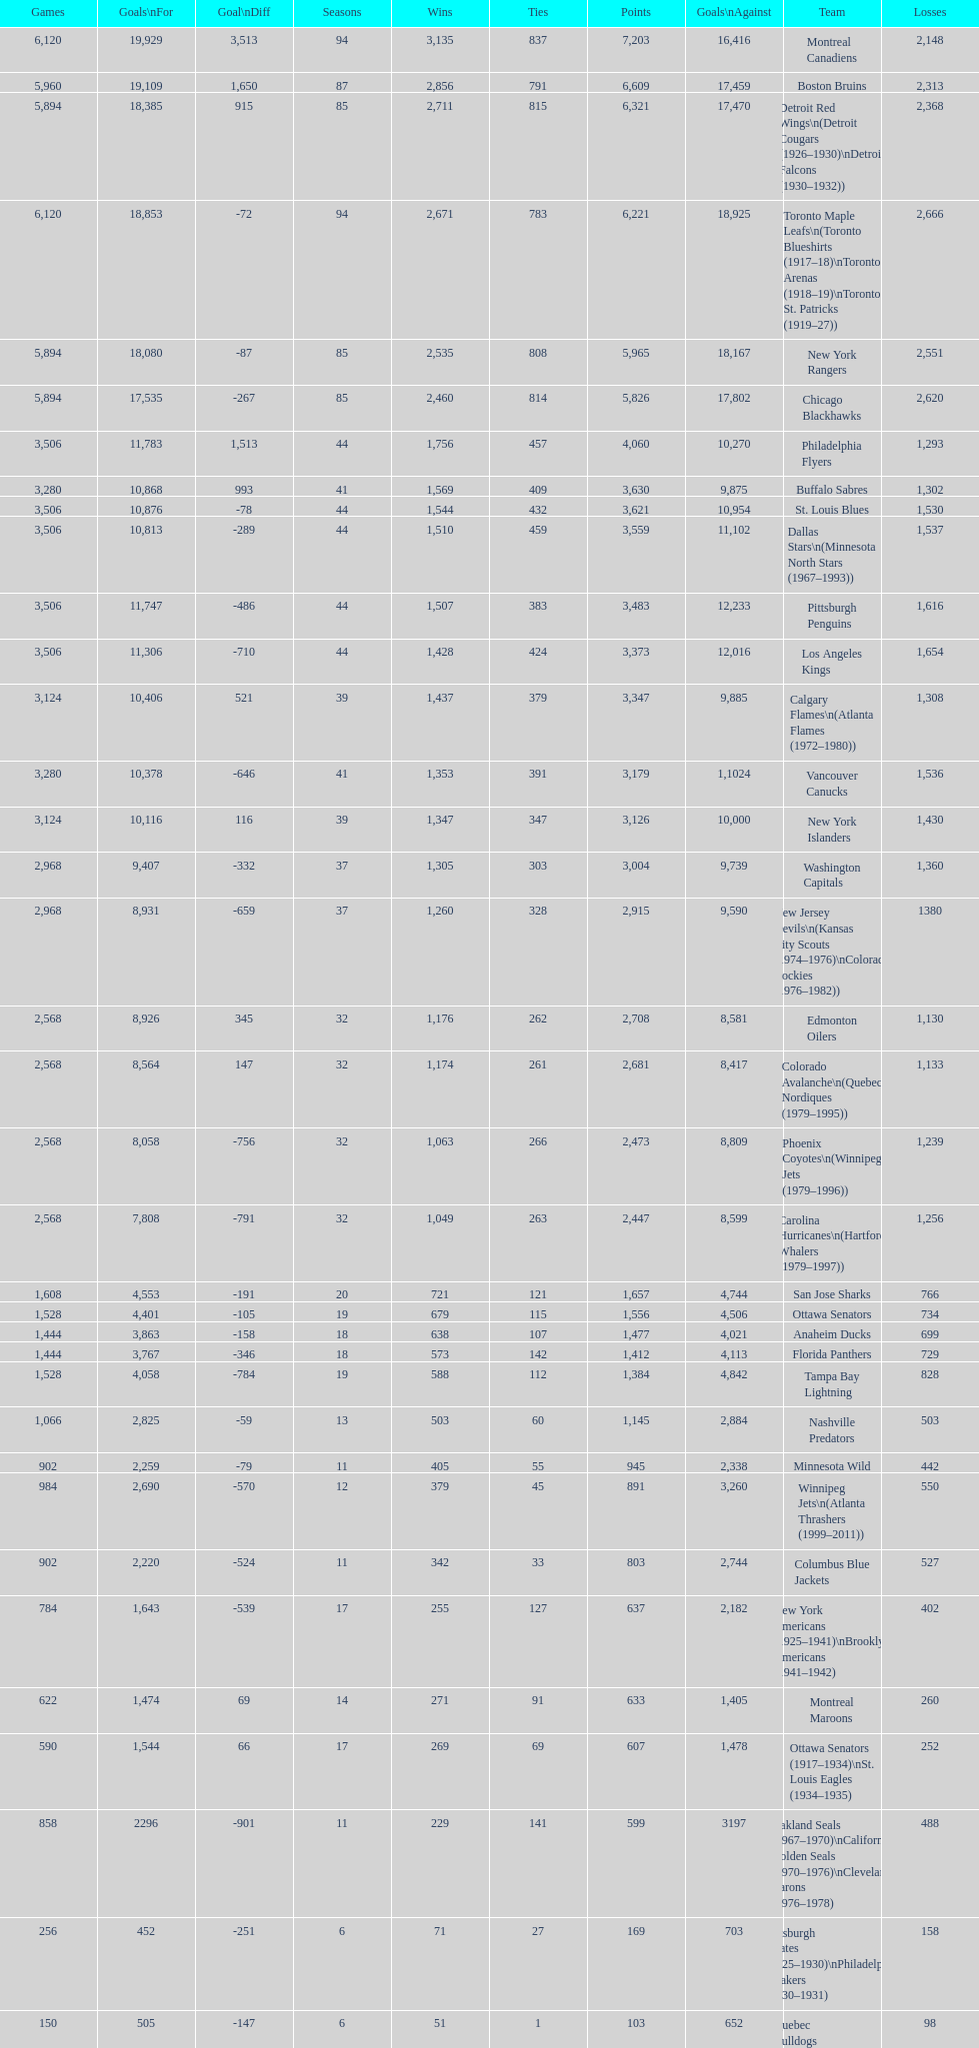How many total points has the lost angeles kings scored? 3,373. 